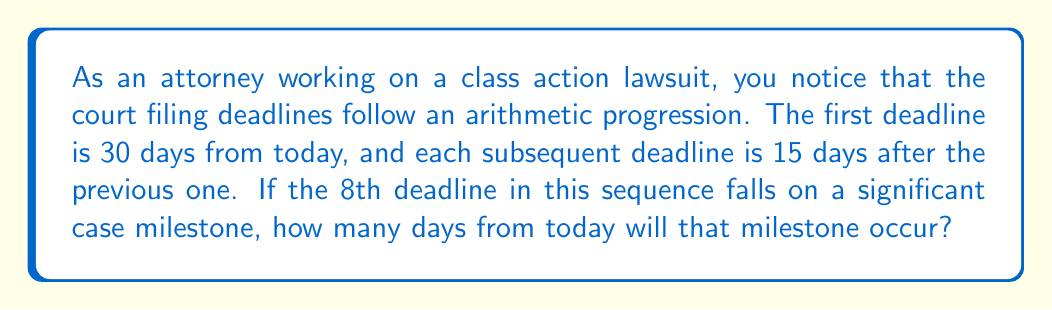Give your solution to this math problem. Let's approach this step-by-step:

1) In an arithmetic progression, the difference between each term is constant. Here, the common difference is 15 days.

2) We can represent this sequence mathematically as:
   $a_n = a_1 + (n-1)d$
   Where $a_n$ is the nth term, $a_1$ is the first term, n is the position of the term, and d is the common difference.

3) We know:
   $a_1 = 30$ (first deadline is 30 days from today)
   $d = 15$ (common difference is 15 days)
   $n = 8$ (we're looking for the 8th deadline)

4) Let's substitute these values into our formula:
   $a_8 = 30 + (8-1)15$

5) Simplify:
   $a_8 = 30 + (7)15$
   $a_8 = 30 + 105$
   $a_8 = 135$

6) Therefore, the 8th deadline, which falls on the significant case milestone, will occur 135 days from today.
Answer: 135 days 